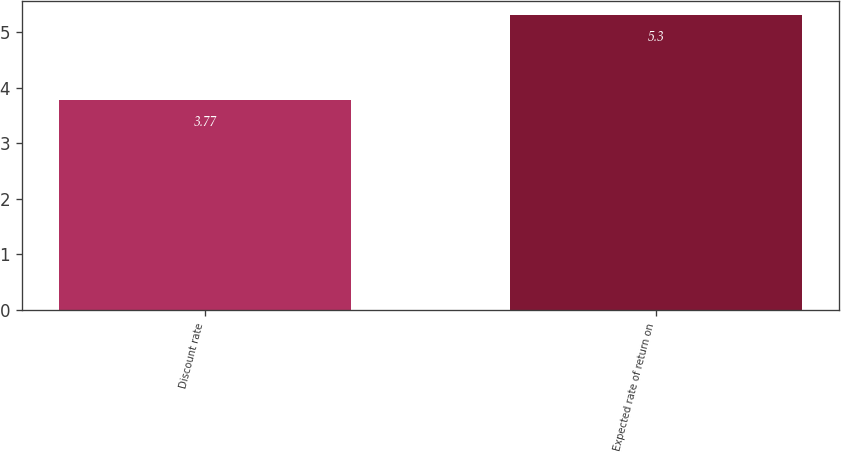Convert chart. <chart><loc_0><loc_0><loc_500><loc_500><bar_chart><fcel>Discount rate<fcel>Expected rate of return on<nl><fcel>3.77<fcel>5.3<nl></chart> 